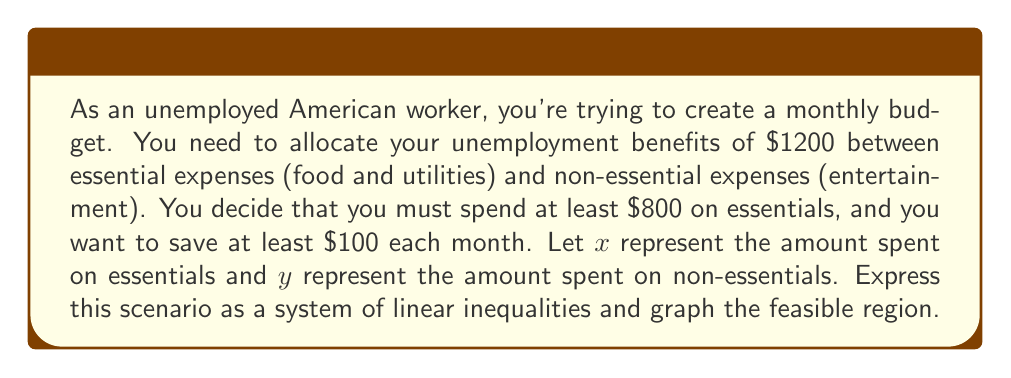Give your solution to this math problem. Let's break this problem down step-by-step:

1) First, let's define our variables:
   $x$ = amount spent on essentials
   $y$ = amount spent on non-essentials

2) Now, let's translate the given information into inequalities:

   a) Total budget constraint: $x + y \leq 1200$
   b) Minimum spending on essentials: $x \geq 800$
   c) Savings requirement: $x + y \leq 1100$ (since $1200 - 100 = 1100$)
   d) Non-negativity constraints: $x \geq 0$, $y \geq 0$

3) Our system of inequalities is:
   $$
   \begin{cases}
   x + y \leq 1200 \\
   x \geq 800 \\
   x + y \leq 1100 \\
   x \geq 0 \\
   y \geq 0
   \end{cases}
   $$

4) To graph this system, we'll plot each line and shade the appropriate regions:

   a) $x + y = 1200$ is a line from (1200, 0) to (0, 1200)
   b) $x = 800$ is a vertical line
   c) $x + y = 1100$ is a line from (1100, 0) to (0, 1100)

5) The feasible region is the area that satisfies all inequalities simultaneously.

[asy]
size(200,200);
import graph;

// Draw axes
axes("x", "y", (0,0), (1300,1300), Arrow);

// Draw constraints
draw((1200,0)--(0,1200), blue);
draw((1100,0)--(0,1100), red);
draw((800,0)--(800,1300), green);

// Shade feasible region
fill((800,0)--(800,300)--(300,800)--(1100,0)--cycle, lightgray);

// Label points
label("(800, 300)", (800,300), E);
label("(1100, 0)", (1100,0), S);
label("(800, 0)", (800,0), SW);

// Label lines
label("x + y = 1200", (600,600), NW, blue);
label("x + y = 1100", (550,550), NW, red);
label("x = 800", (800,650), E, green);

// Label axes
label("x", (1300,0), S);
label("y", (0,1300), W);
[/asy]

The feasible region is the shaded area in the graph. It represents all possible combinations of essential and non-essential expenses that satisfy the budget constraints.
Answer: The system of linear inequalities is:
$$
\begin{cases}
x + y \leq 1200 \\
x \geq 800 \\
x + y \leq 1100 \\
x \geq 0 \\
y \geq 0
\end{cases}
$$
The feasible region is bounded by $x = 800$, $y = 0$, and $x + y = 1100$, with vertices at (800, 0), (800, 300), and (1100, 0). 